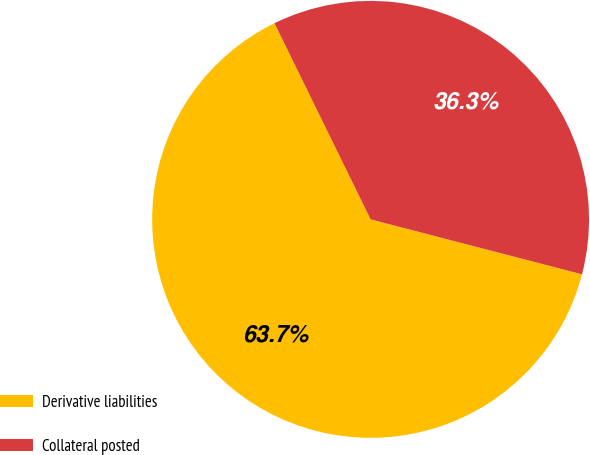Convert chart to OTSL. <chart><loc_0><loc_0><loc_500><loc_500><pie_chart><fcel>Derivative liabilities<fcel>Collateral posted<nl><fcel>63.7%<fcel>36.3%<nl></chart> 